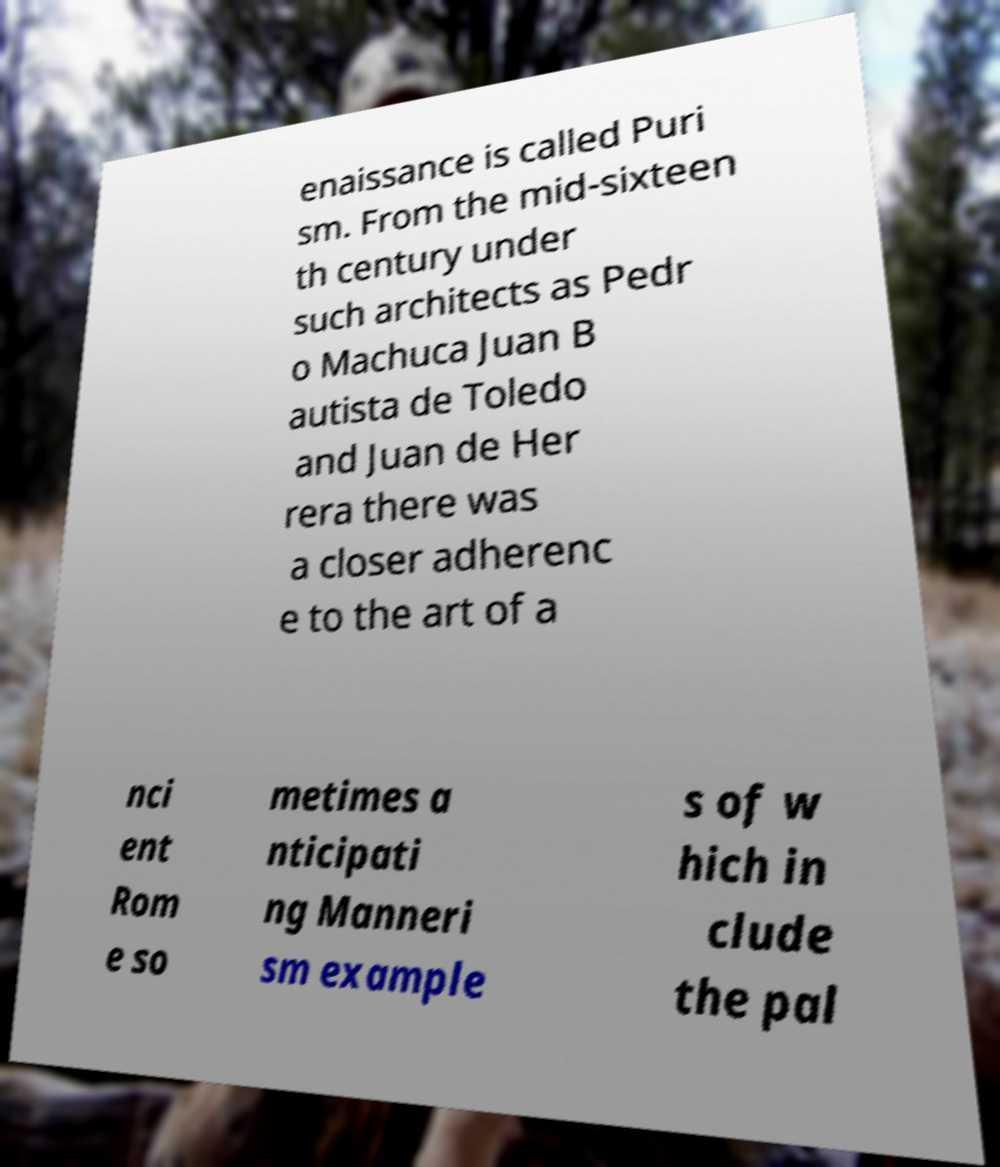Could you assist in decoding the text presented in this image and type it out clearly? enaissance is called Puri sm. From the mid-sixteen th century under such architects as Pedr o Machuca Juan B autista de Toledo and Juan de Her rera there was a closer adherenc e to the art of a nci ent Rom e so metimes a nticipati ng Manneri sm example s of w hich in clude the pal 